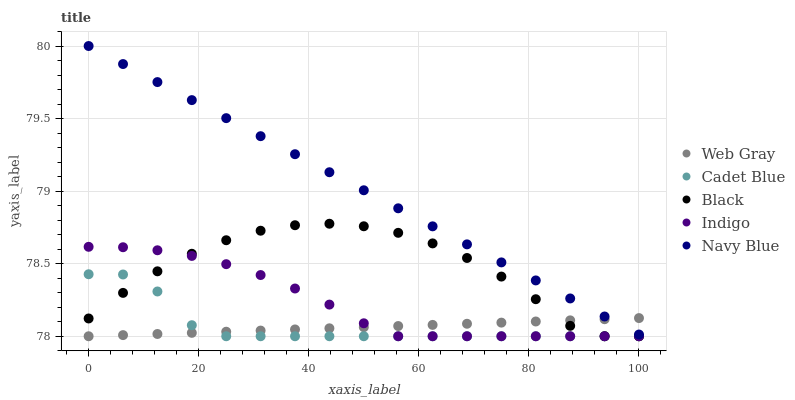Does Web Gray have the minimum area under the curve?
Answer yes or no. Yes. Does Navy Blue have the maximum area under the curve?
Answer yes or no. Yes. Does Indigo have the minimum area under the curve?
Answer yes or no. No. Does Indigo have the maximum area under the curve?
Answer yes or no. No. Is Navy Blue the smoothest?
Answer yes or no. Yes. Is Black the roughest?
Answer yes or no. Yes. Is Indigo the smoothest?
Answer yes or no. No. Is Indigo the roughest?
Answer yes or no. No. Does Cadet Blue have the lowest value?
Answer yes or no. Yes. Does Navy Blue have the lowest value?
Answer yes or no. No. Does Navy Blue have the highest value?
Answer yes or no. Yes. Does Indigo have the highest value?
Answer yes or no. No. Is Black less than Navy Blue?
Answer yes or no. Yes. Is Navy Blue greater than Black?
Answer yes or no. Yes. Does Black intersect Cadet Blue?
Answer yes or no. Yes. Is Black less than Cadet Blue?
Answer yes or no. No. Is Black greater than Cadet Blue?
Answer yes or no. No. Does Black intersect Navy Blue?
Answer yes or no. No. 